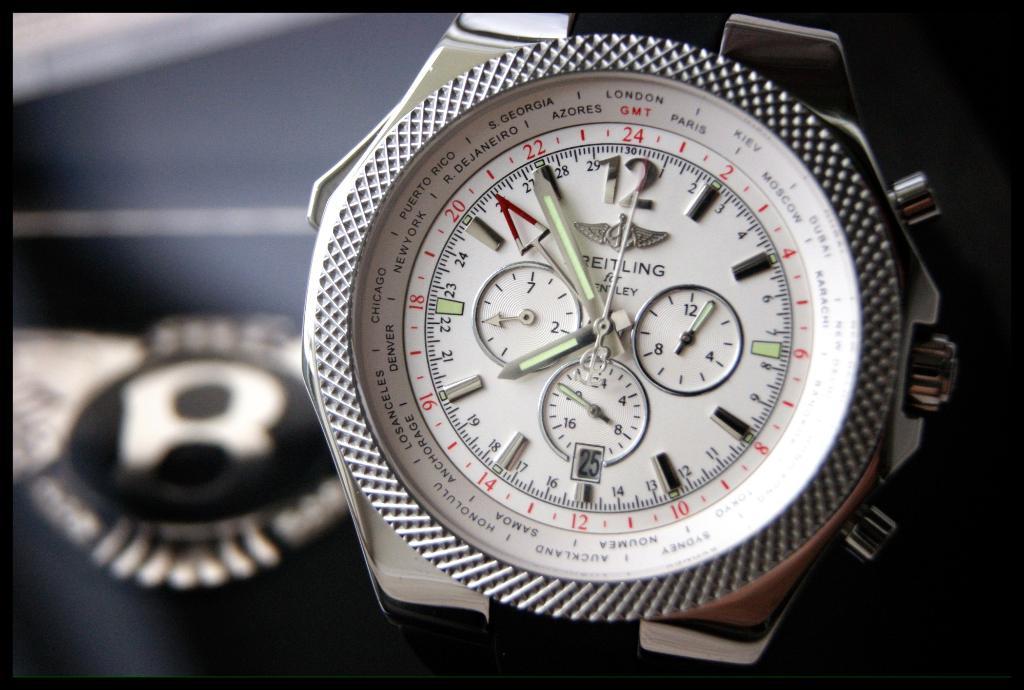What time is it?
Your response must be concise. 7:55. What number does the minute hand point?
Offer a very short reply. 22. 